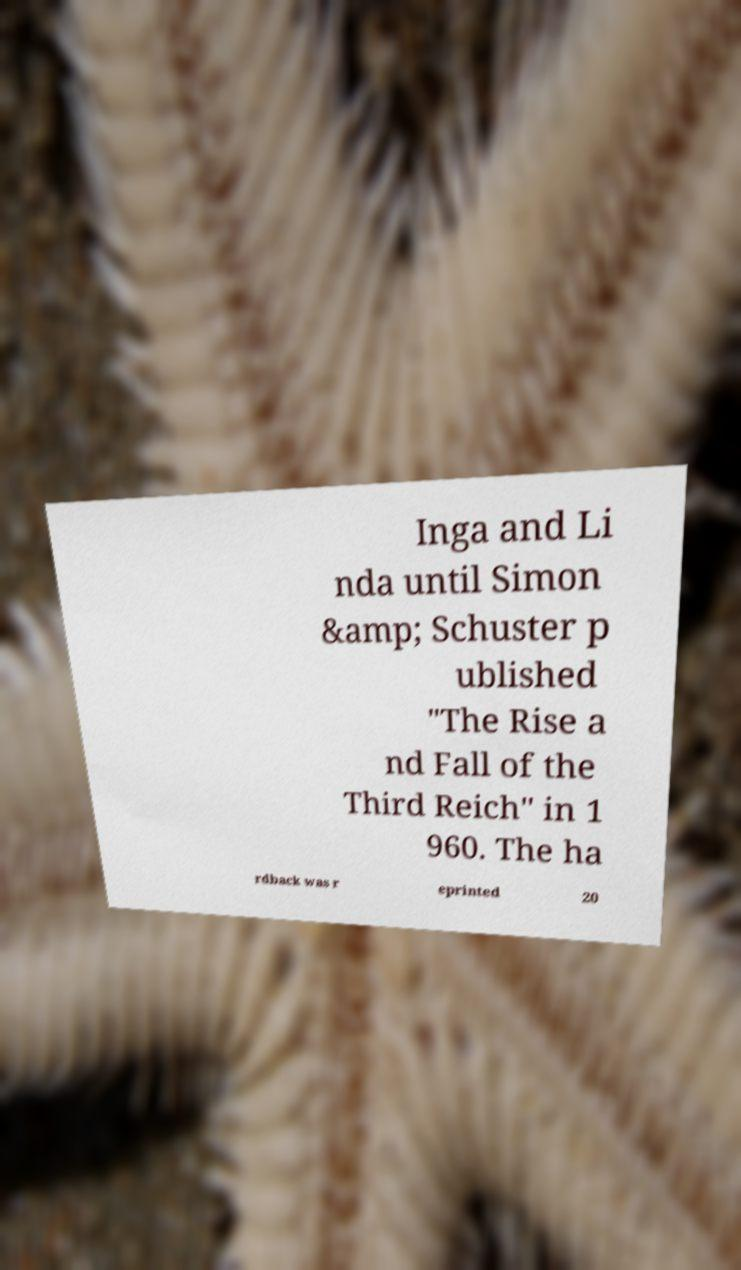Please identify and transcribe the text found in this image. Inga and Li nda until Simon &amp; Schuster p ublished "The Rise a nd Fall of the Third Reich" in 1 960. The ha rdback was r eprinted 20 